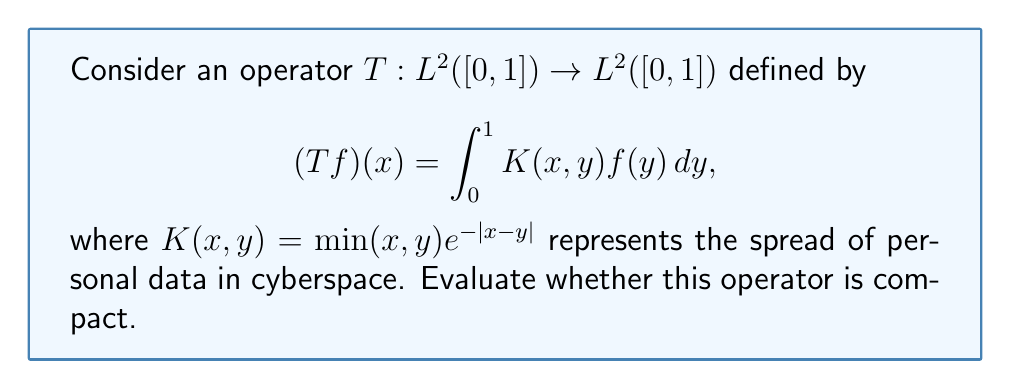What is the answer to this math problem? To determine if the operator $T$ is compact, we'll follow these steps:

1) First, recall that an integral operator with a continuous kernel on a compact domain is compact.

2) Our kernel $K(x,y) = \min(x,y)e^{-|x-y|}$ is defined on the compact domain $[0,1] \times [0,1]$.

3) Let's check the continuity of $K(x,y)$:
   - The function $\min(x,y)$ is continuous on $[0,1] \times [0,1]$.
   - The function $e^{-|x-y|}$ is also continuous on $[0,1] \times [0,1]$.
   - The product of two continuous functions is continuous.

4) Therefore, $K(x,y)$ is continuous on $[0,1] \times [0,1]$.

5) Since we have a continuous kernel on a compact domain, the operator $T$ is compact.

This result aligns with the idea that the spread of personal data in cyberspace, while potentially far-reaching, is ultimately bounded and can be represented by a compact operator. This mathematical framework provides a nuanced perspective on privacy rights in the digital age, reflecting the complexity of information dissemination and its limits.
Answer: The operator $T$ is compact. 